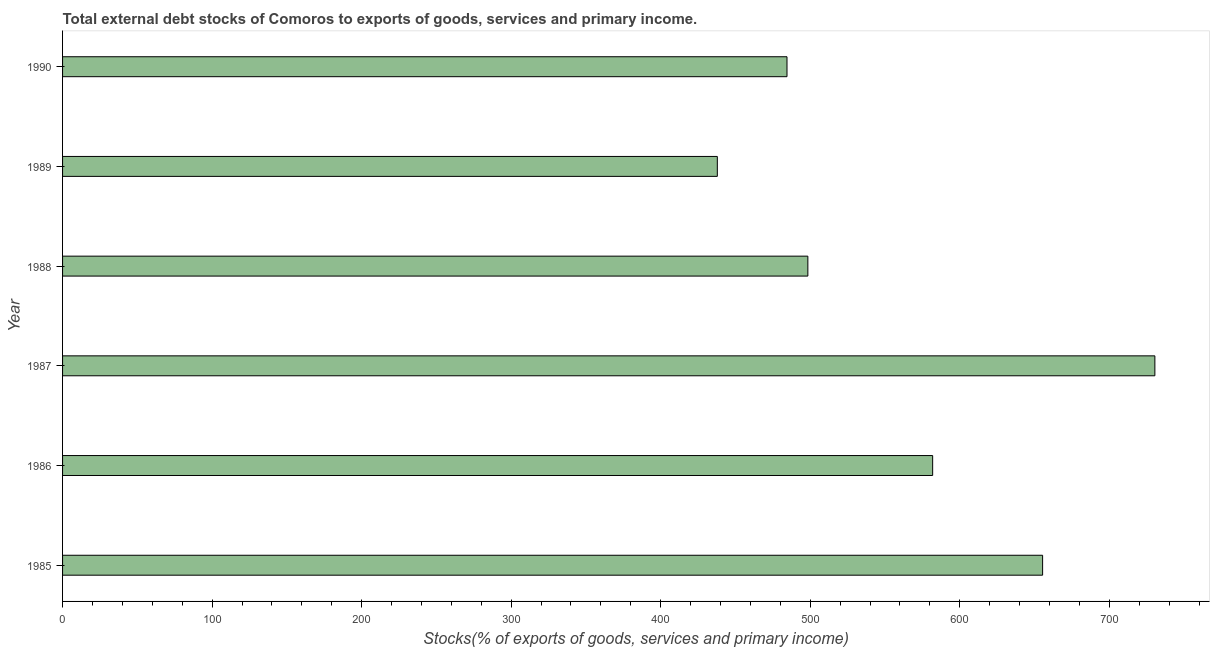What is the title of the graph?
Provide a short and direct response. Total external debt stocks of Comoros to exports of goods, services and primary income. What is the label or title of the X-axis?
Offer a very short reply. Stocks(% of exports of goods, services and primary income). What is the label or title of the Y-axis?
Make the answer very short. Year. What is the external debt stocks in 1987?
Your response must be concise. 730.49. Across all years, what is the maximum external debt stocks?
Offer a very short reply. 730.49. Across all years, what is the minimum external debt stocks?
Ensure brevity in your answer.  437.88. What is the sum of the external debt stocks?
Keep it short and to the point. 3388.53. What is the difference between the external debt stocks in 1987 and 1988?
Make the answer very short. 232.07. What is the average external debt stocks per year?
Keep it short and to the point. 564.75. What is the median external debt stocks?
Provide a short and direct response. 540.15. Is the difference between the external debt stocks in 1988 and 1989 greater than the difference between any two years?
Give a very brief answer. No. What is the difference between the highest and the second highest external debt stocks?
Provide a short and direct response. 75.08. Is the sum of the external debt stocks in 1988 and 1990 greater than the maximum external debt stocks across all years?
Provide a short and direct response. Yes. What is the difference between the highest and the lowest external debt stocks?
Make the answer very short. 292.61. In how many years, is the external debt stocks greater than the average external debt stocks taken over all years?
Make the answer very short. 3. How many bars are there?
Ensure brevity in your answer.  6. Are all the bars in the graph horizontal?
Provide a short and direct response. Yes. What is the difference between two consecutive major ticks on the X-axis?
Your response must be concise. 100. Are the values on the major ticks of X-axis written in scientific E-notation?
Provide a short and direct response. No. What is the Stocks(% of exports of goods, services and primary income) in 1985?
Your response must be concise. 655.41. What is the Stocks(% of exports of goods, services and primary income) of 1986?
Keep it short and to the point. 581.88. What is the Stocks(% of exports of goods, services and primary income) of 1987?
Your answer should be very brief. 730.49. What is the Stocks(% of exports of goods, services and primary income) in 1988?
Your answer should be very brief. 498.42. What is the Stocks(% of exports of goods, services and primary income) of 1989?
Keep it short and to the point. 437.88. What is the Stocks(% of exports of goods, services and primary income) in 1990?
Your answer should be compact. 484.47. What is the difference between the Stocks(% of exports of goods, services and primary income) in 1985 and 1986?
Provide a succinct answer. 73.53. What is the difference between the Stocks(% of exports of goods, services and primary income) in 1985 and 1987?
Your answer should be compact. -75.08. What is the difference between the Stocks(% of exports of goods, services and primary income) in 1985 and 1988?
Make the answer very short. 156.99. What is the difference between the Stocks(% of exports of goods, services and primary income) in 1985 and 1989?
Offer a terse response. 217.53. What is the difference between the Stocks(% of exports of goods, services and primary income) in 1985 and 1990?
Make the answer very short. 170.94. What is the difference between the Stocks(% of exports of goods, services and primary income) in 1986 and 1987?
Make the answer very short. -148.61. What is the difference between the Stocks(% of exports of goods, services and primary income) in 1986 and 1988?
Give a very brief answer. 83.46. What is the difference between the Stocks(% of exports of goods, services and primary income) in 1986 and 1989?
Give a very brief answer. 144. What is the difference between the Stocks(% of exports of goods, services and primary income) in 1986 and 1990?
Provide a short and direct response. 97.41. What is the difference between the Stocks(% of exports of goods, services and primary income) in 1987 and 1988?
Your response must be concise. 232.07. What is the difference between the Stocks(% of exports of goods, services and primary income) in 1987 and 1989?
Your response must be concise. 292.61. What is the difference between the Stocks(% of exports of goods, services and primary income) in 1987 and 1990?
Ensure brevity in your answer.  246.02. What is the difference between the Stocks(% of exports of goods, services and primary income) in 1988 and 1989?
Offer a very short reply. 60.54. What is the difference between the Stocks(% of exports of goods, services and primary income) in 1988 and 1990?
Keep it short and to the point. 13.95. What is the difference between the Stocks(% of exports of goods, services and primary income) in 1989 and 1990?
Ensure brevity in your answer.  -46.59. What is the ratio of the Stocks(% of exports of goods, services and primary income) in 1985 to that in 1986?
Give a very brief answer. 1.13. What is the ratio of the Stocks(% of exports of goods, services and primary income) in 1985 to that in 1987?
Offer a very short reply. 0.9. What is the ratio of the Stocks(% of exports of goods, services and primary income) in 1985 to that in 1988?
Provide a short and direct response. 1.31. What is the ratio of the Stocks(% of exports of goods, services and primary income) in 1985 to that in 1989?
Provide a short and direct response. 1.5. What is the ratio of the Stocks(% of exports of goods, services and primary income) in 1985 to that in 1990?
Ensure brevity in your answer.  1.35. What is the ratio of the Stocks(% of exports of goods, services and primary income) in 1986 to that in 1987?
Your answer should be compact. 0.8. What is the ratio of the Stocks(% of exports of goods, services and primary income) in 1986 to that in 1988?
Offer a very short reply. 1.17. What is the ratio of the Stocks(% of exports of goods, services and primary income) in 1986 to that in 1989?
Offer a terse response. 1.33. What is the ratio of the Stocks(% of exports of goods, services and primary income) in 1986 to that in 1990?
Make the answer very short. 1.2. What is the ratio of the Stocks(% of exports of goods, services and primary income) in 1987 to that in 1988?
Offer a very short reply. 1.47. What is the ratio of the Stocks(% of exports of goods, services and primary income) in 1987 to that in 1989?
Offer a very short reply. 1.67. What is the ratio of the Stocks(% of exports of goods, services and primary income) in 1987 to that in 1990?
Give a very brief answer. 1.51. What is the ratio of the Stocks(% of exports of goods, services and primary income) in 1988 to that in 1989?
Your answer should be compact. 1.14. What is the ratio of the Stocks(% of exports of goods, services and primary income) in 1988 to that in 1990?
Your answer should be compact. 1.03. What is the ratio of the Stocks(% of exports of goods, services and primary income) in 1989 to that in 1990?
Give a very brief answer. 0.9. 